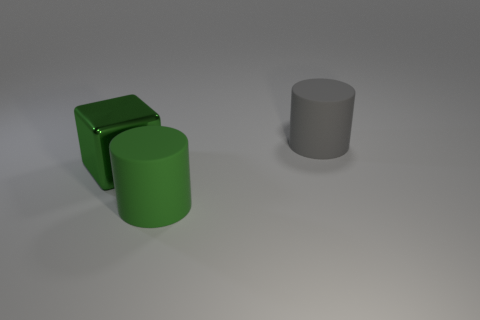Is the gray object the same size as the metallic object?
Your answer should be very brief. Yes. What number of other objects are there of the same size as the green cylinder?
Your answer should be very brief. 2. What is the shape of the big rubber thing to the left of the rubber thing that is behind the green object right of the large shiny object?
Offer a terse response. Cylinder. How many things are either objects that are in front of the large gray matte thing or large matte cylinders that are behind the shiny cube?
Your answer should be compact. 3. How big is the metallic cube that is behind the big matte cylinder in front of the green metallic block?
Your answer should be compact. Large. There is a big rubber cylinder that is on the left side of the big gray matte cylinder; does it have the same color as the big cube?
Keep it short and to the point. Yes. Is there another big gray thing that has the same shape as the big metal object?
Your response must be concise. No. What is the color of the block that is the same size as the gray object?
Make the answer very short. Green. What is the size of the matte thing that is left of the gray rubber object?
Ensure brevity in your answer.  Large. Are there any large gray cylinders that are behind the big rubber thing in front of the large gray object?
Your answer should be compact. Yes. 